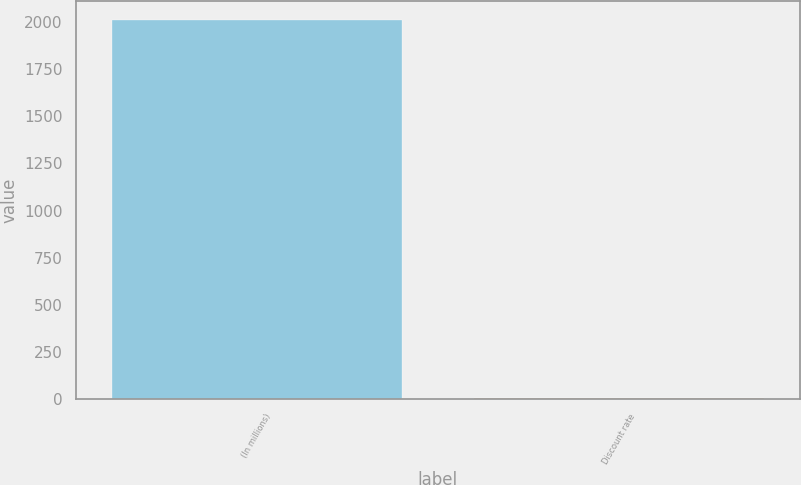<chart> <loc_0><loc_0><loc_500><loc_500><bar_chart><fcel>(In millions)<fcel>Discount rate<nl><fcel>2010<fcel>5.94<nl></chart> 